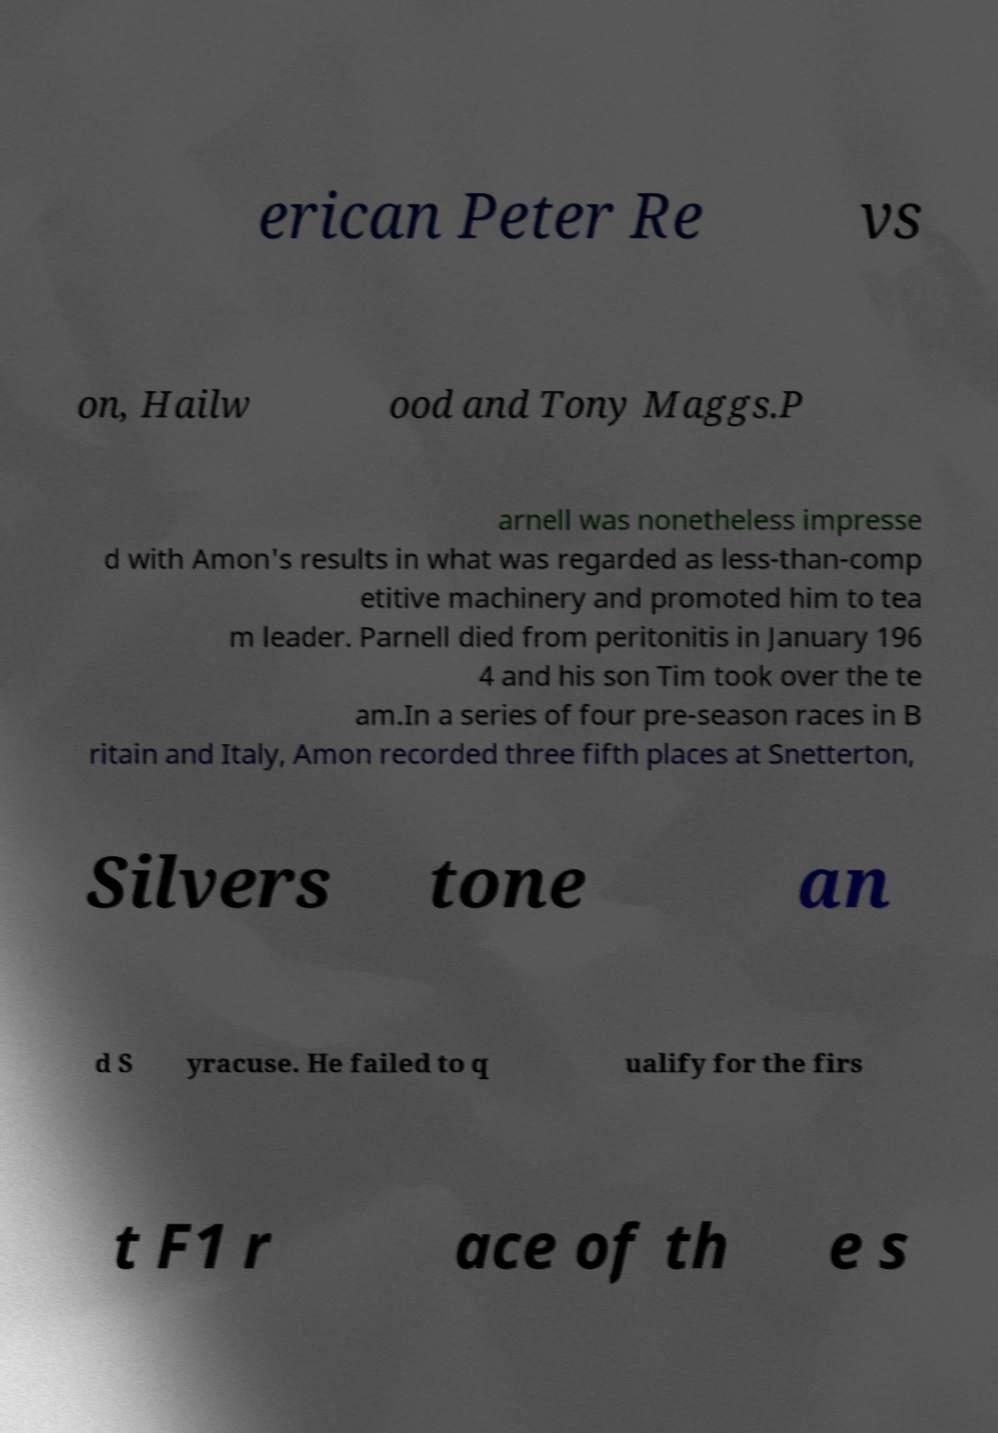Can you accurately transcribe the text from the provided image for me? erican Peter Re vs on, Hailw ood and Tony Maggs.P arnell was nonetheless impresse d with Amon's results in what was regarded as less-than-comp etitive machinery and promoted him to tea m leader. Parnell died from peritonitis in January 196 4 and his son Tim took over the te am.In a series of four pre-season races in B ritain and Italy, Amon recorded three fifth places at Snetterton, Silvers tone an d S yracuse. He failed to q ualify for the firs t F1 r ace of th e s 